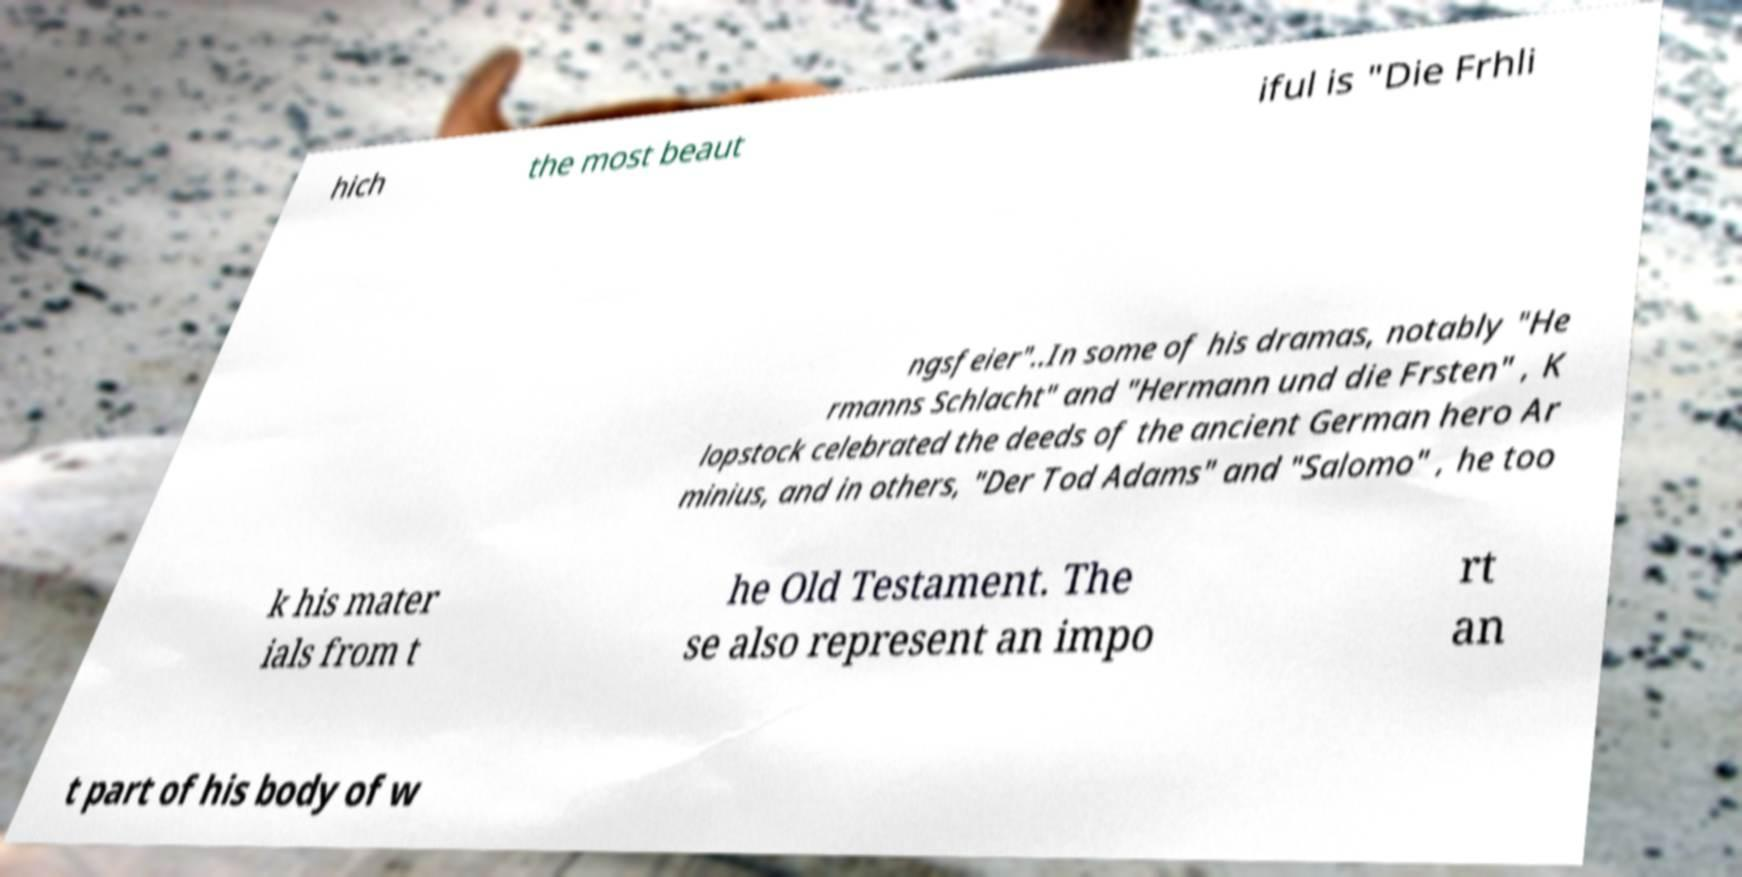I need the written content from this picture converted into text. Can you do that? hich the most beaut iful is "Die Frhli ngsfeier"..In some of his dramas, notably "He rmanns Schlacht" and "Hermann und die Frsten" , K lopstock celebrated the deeds of the ancient German hero Ar minius, and in others, "Der Tod Adams" and "Salomo" , he too k his mater ials from t he Old Testament. The se also represent an impo rt an t part of his body of w 